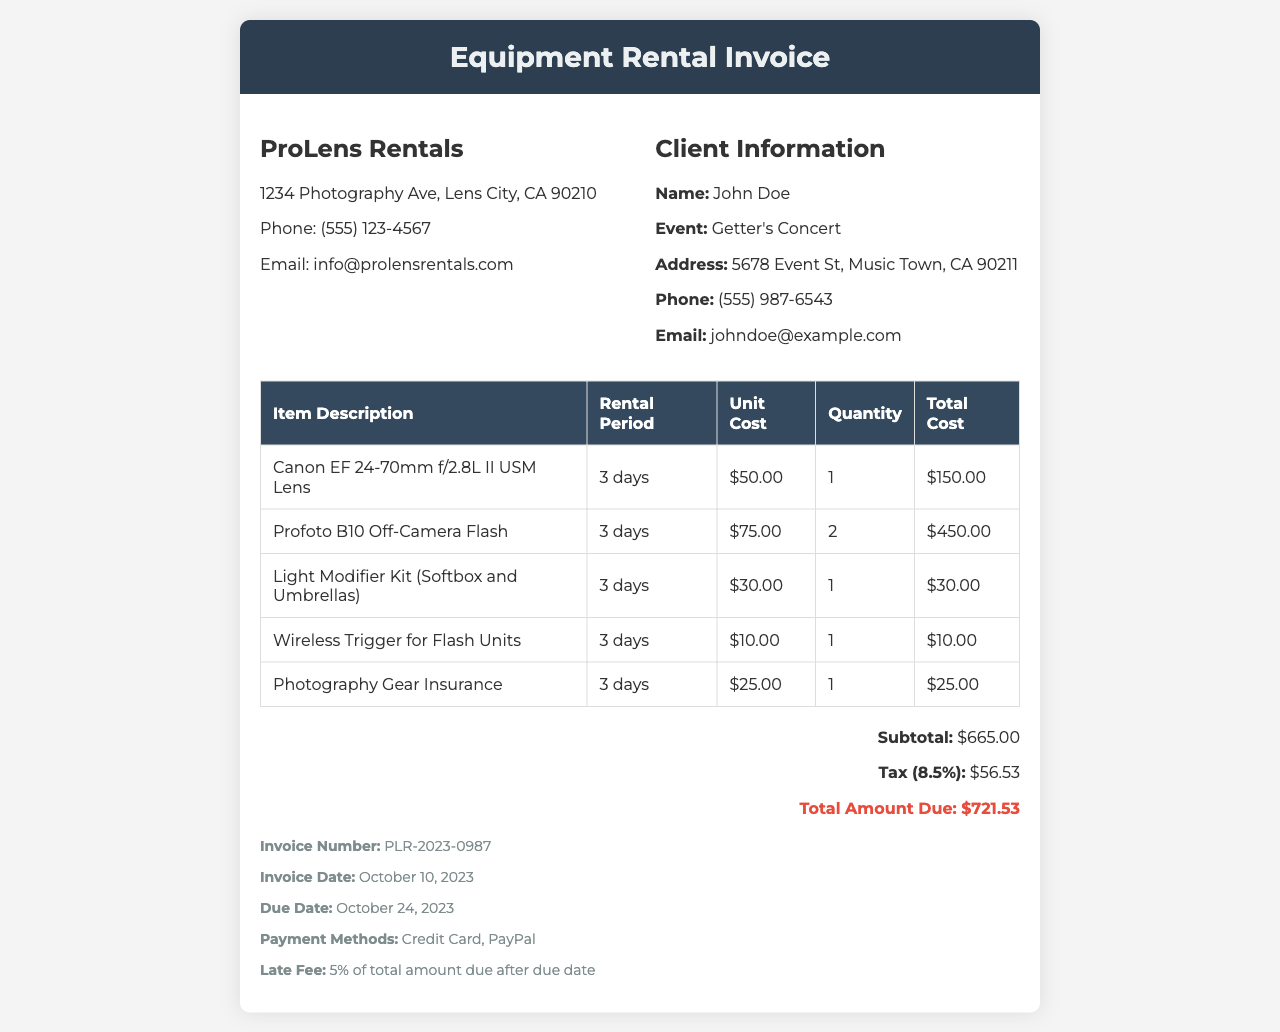What is the name of the rental company? The rental company's name is displayed in the header of the invoice.
Answer: ProLens Rentals What is the total amount due? The total amount due is calculated by adding the subtotal and tax in the invoice.
Answer: $721.53 What is the rental period for the Canon EF Lens? The rental period is mentioned in the item description section for that lens.
Answer: 3 days How many Profoto B10 Off-Camera Flashes were rented? The quantity of Profoto B10 Off-Camera Flash is listed in the invoice table.
Answer: 2 What is the invoice date? The invoice date is indicated in the payment terms section of the document.
Answer: October 10, 2023 What is the late fee percentage? The late fee percentage is specified in the payment terms section of the invoice.
Answer: 5% What is the subtotal amount before tax? The subtotal amount is specified in the invoice summary section.
Answer: $665.00 What insurance charge is included in the invoice? The insurance charge appears as a line item in the invoice table.
Answer: $25.00 What is the address of the rental company? The address for ProLens Rentals is listed in the company details section of the document.
Answer: 1234 Photography Ave, Lens City, CA 90210 